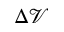<formula> <loc_0><loc_0><loc_500><loc_500>\Delta \mathcal { V }</formula> 